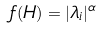<formula> <loc_0><loc_0><loc_500><loc_500>f ( H ) = | \lambda _ { i } | ^ { \alpha }</formula> 